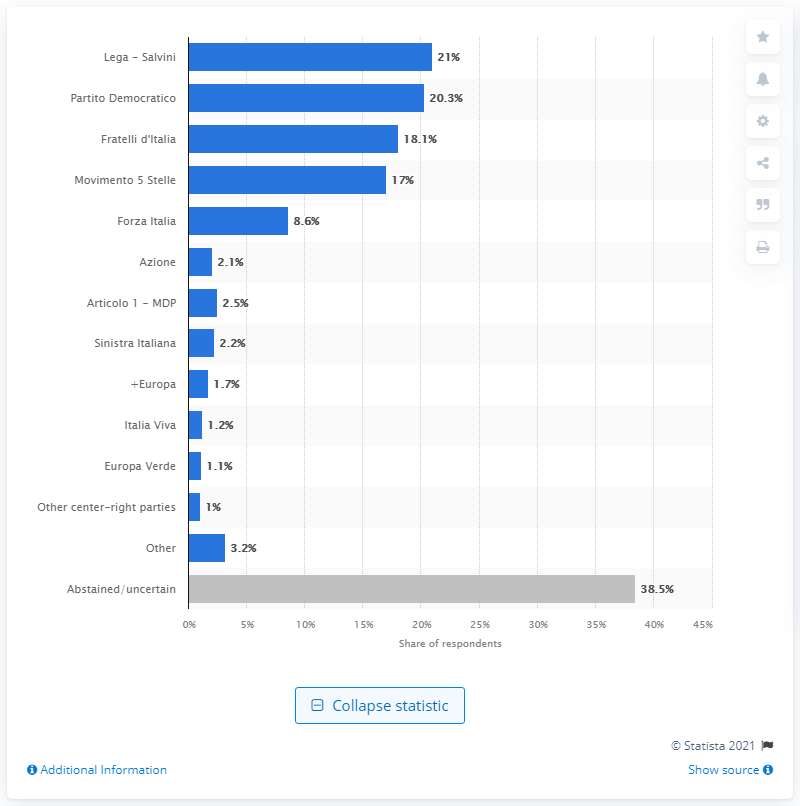Draw attention to some important aspects in this diagram. According to the poll results, 18.1% of respondents indicated that they would vote for Fratelli d'Italia. In 2021, 38.5% of Italians were unsure about their voting intentions. According to the survey, 21% of Italians declared that they voted for Lega - Salvini. According to the data, 20.3% of Italians would vote for Partito Democratico. 